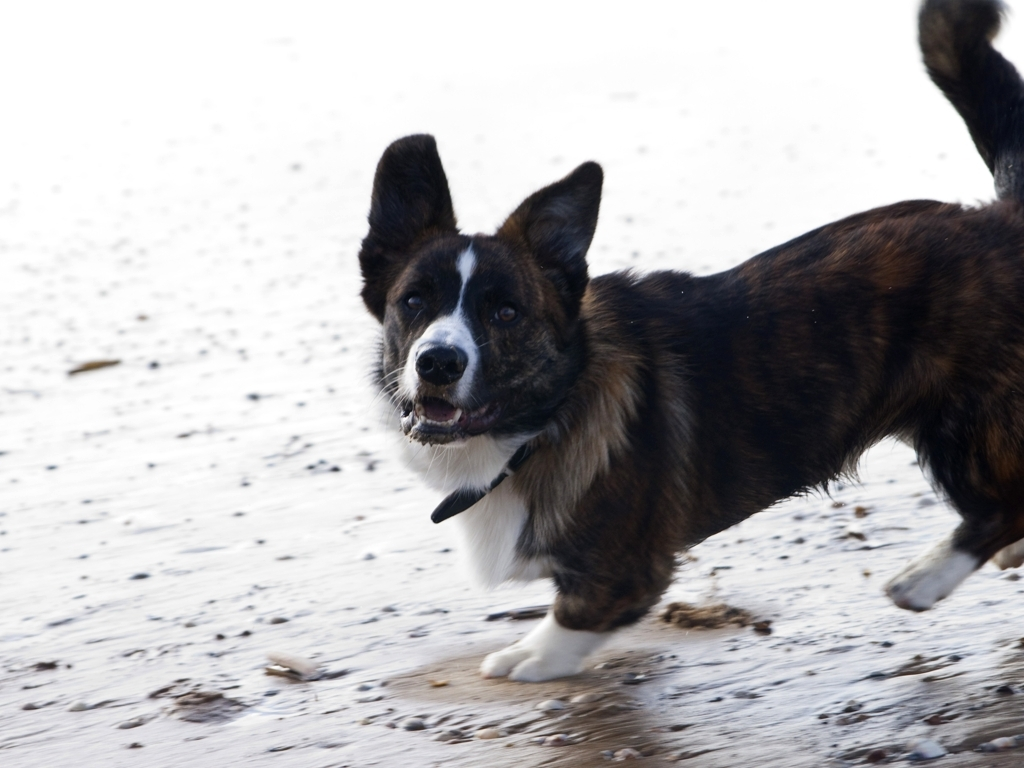Can you describe the setting where the dog is found? Certainly! The dog is on a sandy area, most likely a beach, given the presence of what appears to be wet sand and small debris. The photo's background is overexposed, suggesting it might be a bright day although specifics are hard to confirm. 